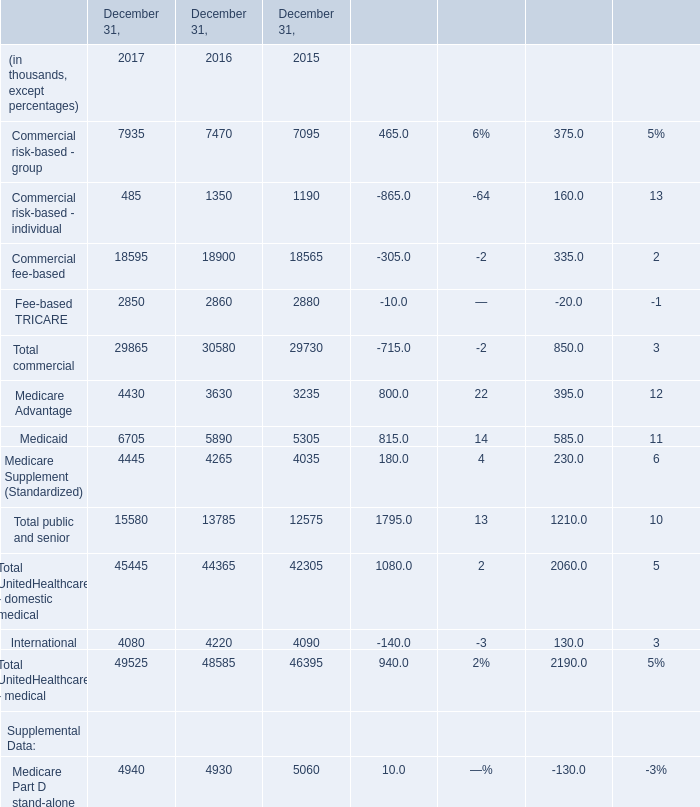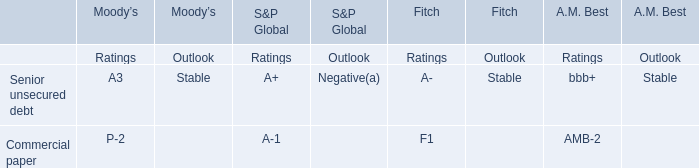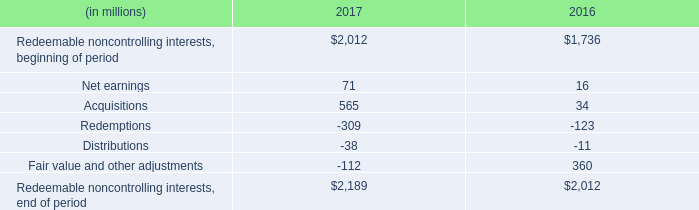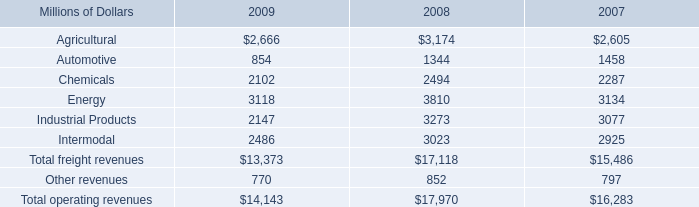for 2009 , what was freight revenue per route mile? 
Computations: ((13373 * 1000000) / 32094)
Answer: 416682.2459. 